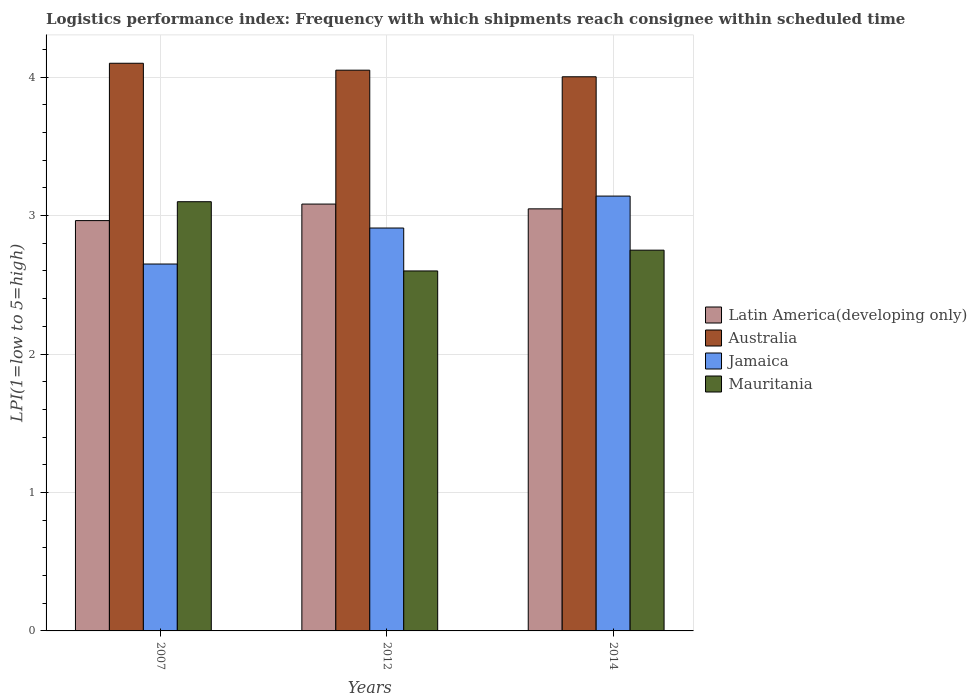How many different coloured bars are there?
Offer a very short reply. 4. Are the number of bars on each tick of the X-axis equal?
Your answer should be very brief. Yes. How many bars are there on the 3rd tick from the left?
Make the answer very short. 4. How many bars are there on the 1st tick from the right?
Give a very brief answer. 4. In how many cases, is the number of bars for a given year not equal to the number of legend labels?
Keep it short and to the point. 0. What is the logistics performance index in Jamaica in 2012?
Give a very brief answer. 2.91. Across all years, what is the maximum logistics performance index in Jamaica?
Keep it short and to the point. 3.14. Across all years, what is the minimum logistics performance index in Jamaica?
Offer a very short reply. 2.65. In which year was the logistics performance index in Mauritania maximum?
Your response must be concise. 2007. What is the total logistics performance index in Australia in the graph?
Make the answer very short. 12.15. What is the difference between the logistics performance index in Mauritania in 2007 and that in 2014?
Your response must be concise. 0.35. What is the difference between the logistics performance index in Mauritania in 2007 and the logistics performance index in Australia in 2012?
Ensure brevity in your answer.  -0.95. What is the average logistics performance index in Latin America(developing only) per year?
Ensure brevity in your answer.  3.03. In the year 2012, what is the difference between the logistics performance index in Jamaica and logistics performance index in Australia?
Give a very brief answer. -1.14. In how many years, is the logistics performance index in Latin America(developing only) greater than 0.8?
Offer a terse response. 3. What is the ratio of the logistics performance index in Australia in 2012 to that in 2014?
Offer a terse response. 1.01. Is the logistics performance index in Latin America(developing only) in 2012 less than that in 2014?
Provide a short and direct response. No. What is the difference between the highest and the second highest logistics performance index in Australia?
Ensure brevity in your answer.  0.05. What is the difference between the highest and the lowest logistics performance index in Australia?
Give a very brief answer. 0.1. In how many years, is the logistics performance index in Latin America(developing only) greater than the average logistics performance index in Latin America(developing only) taken over all years?
Your answer should be very brief. 2. Is the sum of the logistics performance index in Australia in 2007 and 2014 greater than the maximum logistics performance index in Jamaica across all years?
Provide a succinct answer. Yes. What does the 1st bar from the left in 2012 represents?
Give a very brief answer. Latin America(developing only). How many bars are there?
Offer a terse response. 12. How many years are there in the graph?
Give a very brief answer. 3. Are the values on the major ticks of Y-axis written in scientific E-notation?
Provide a succinct answer. No. Does the graph contain any zero values?
Ensure brevity in your answer.  No. Where does the legend appear in the graph?
Provide a short and direct response. Center right. What is the title of the graph?
Provide a succinct answer. Logistics performance index: Frequency with which shipments reach consignee within scheduled time. What is the label or title of the X-axis?
Make the answer very short. Years. What is the label or title of the Y-axis?
Offer a very short reply. LPI(1=low to 5=high). What is the LPI(1=low to 5=high) in Latin America(developing only) in 2007?
Ensure brevity in your answer.  2.96. What is the LPI(1=low to 5=high) of Jamaica in 2007?
Make the answer very short. 2.65. What is the LPI(1=low to 5=high) in Latin America(developing only) in 2012?
Make the answer very short. 3.08. What is the LPI(1=low to 5=high) in Australia in 2012?
Make the answer very short. 4.05. What is the LPI(1=low to 5=high) of Jamaica in 2012?
Offer a very short reply. 2.91. What is the LPI(1=low to 5=high) in Latin America(developing only) in 2014?
Keep it short and to the point. 3.05. What is the LPI(1=low to 5=high) in Australia in 2014?
Your answer should be very brief. 4. What is the LPI(1=low to 5=high) of Jamaica in 2014?
Provide a short and direct response. 3.14. What is the LPI(1=low to 5=high) of Mauritania in 2014?
Your answer should be compact. 2.75. Across all years, what is the maximum LPI(1=low to 5=high) of Latin America(developing only)?
Your response must be concise. 3.08. Across all years, what is the maximum LPI(1=low to 5=high) of Jamaica?
Offer a terse response. 3.14. Across all years, what is the minimum LPI(1=low to 5=high) of Latin America(developing only)?
Your response must be concise. 2.96. Across all years, what is the minimum LPI(1=low to 5=high) in Australia?
Your answer should be very brief. 4. Across all years, what is the minimum LPI(1=low to 5=high) of Jamaica?
Ensure brevity in your answer.  2.65. What is the total LPI(1=low to 5=high) in Latin America(developing only) in the graph?
Your answer should be compact. 9.09. What is the total LPI(1=low to 5=high) of Australia in the graph?
Your response must be concise. 12.15. What is the total LPI(1=low to 5=high) in Jamaica in the graph?
Make the answer very short. 8.7. What is the total LPI(1=low to 5=high) in Mauritania in the graph?
Offer a very short reply. 8.45. What is the difference between the LPI(1=low to 5=high) in Latin America(developing only) in 2007 and that in 2012?
Give a very brief answer. -0.12. What is the difference between the LPI(1=low to 5=high) of Australia in 2007 and that in 2012?
Make the answer very short. 0.05. What is the difference between the LPI(1=low to 5=high) in Jamaica in 2007 and that in 2012?
Provide a short and direct response. -0.26. What is the difference between the LPI(1=low to 5=high) of Latin America(developing only) in 2007 and that in 2014?
Provide a succinct answer. -0.08. What is the difference between the LPI(1=low to 5=high) in Australia in 2007 and that in 2014?
Your answer should be very brief. 0.1. What is the difference between the LPI(1=low to 5=high) in Jamaica in 2007 and that in 2014?
Keep it short and to the point. -0.49. What is the difference between the LPI(1=low to 5=high) in Latin America(developing only) in 2012 and that in 2014?
Offer a very short reply. 0.03. What is the difference between the LPI(1=low to 5=high) of Australia in 2012 and that in 2014?
Your response must be concise. 0.05. What is the difference between the LPI(1=low to 5=high) of Jamaica in 2012 and that in 2014?
Provide a succinct answer. -0.23. What is the difference between the LPI(1=low to 5=high) of Latin America(developing only) in 2007 and the LPI(1=low to 5=high) of Australia in 2012?
Keep it short and to the point. -1.09. What is the difference between the LPI(1=low to 5=high) in Latin America(developing only) in 2007 and the LPI(1=low to 5=high) in Jamaica in 2012?
Offer a very short reply. 0.05. What is the difference between the LPI(1=low to 5=high) of Latin America(developing only) in 2007 and the LPI(1=low to 5=high) of Mauritania in 2012?
Provide a succinct answer. 0.36. What is the difference between the LPI(1=low to 5=high) of Australia in 2007 and the LPI(1=low to 5=high) of Jamaica in 2012?
Your response must be concise. 1.19. What is the difference between the LPI(1=low to 5=high) in Australia in 2007 and the LPI(1=low to 5=high) in Mauritania in 2012?
Ensure brevity in your answer.  1.5. What is the difference between the LPI(1=low to 5=high) in Latin America(developing only) in 2007 and the LPI(1=low to 5=high) in Australia in 2014?
Provide a short and direct response. -1.04. What is the difference between the LPI(1=low to 5=high) in Latin America(developing only) in 2007 and the LPI(1=low to 5=high) in Jamaica in 2014?
Your answer should be very brief. -0.18. What is the difference between the LPI(1=low to 5=high) in Latin America(developing only) in 2007 and the LPI(1=low to 5=high) in Mauritania in 2014?
Provide a succinct answer. 0.21. What is the difference between the LPI(1=low to 5=high) of Australia in 2007 and the LPI(1=low to 5=high) of Jamaica in 2014?
Give a very brief answer. 0.96. What is the difference between the LPI(1=low to 5=high) of Australia in 2007 and the LPI(1=low to 5=high) of Mauritania in 2014?
Ensure brevity in your answer.  1.35. What is the difference between the LPI(1=low to 5=high) of Jamaica in 2007 and the LPI(1=low to 5=high) of Mauritania in 2014?
Keep it short and to the point. -0.1. What is the difference between the LPI(1=low to 5=high) in Latin America(developing only) in 2012 and the LPI(1=low to 5=high) in Australia in 2014?
Offer a terse response. -0.92. What is the difference between the LPI(1=low to 5=high) of Latin America(developing only) in 2012 and the LPI(1=low to 5=high) of Jamaica in 2014?
Offer a very short reply. -0.06. What is the difference between the LPI(1=low to 5=high) in Latin America(developing only) in 2012 and the LPI(1=low to 5=high) in Mauritania in 2014?
Offer a very short reply. 0.33. What is the difference between the LPI(1=low to 5=high) of Australia in 2012 and the LPI(1=low to 5=high) of Jamaica in 2014?
Make the answer very short. 0.91. What is the difference between the LPI(1=low to 5=high) of Jamaica in 2012 and the LPI(1=low to 5=high) of Mauritania in 2014?
Give a very brief answer. 0.16. What is the average LPI(1=low to 5=high) of Latin America(developing only) per year?
Your answer should be compact. 3.03. What is the average LPI(1=low to 5=high) in Australia per year?
Your response must be concise. 4.05. What is the average LPI(1=low to 5=high) in Jamaica per year?
Provide a short and direct response. 2.9. What is the average LPI(1=low to 5=high) of Mauritania per year?
Give a very brief answer. 2.82. In the year 2007, what is the difference between the LPI(1=low to 5=high) in Latin America(developing only) and LPI(1=low to 5=high) in Australia?
Provide a succinct answer. -1.14. In the year 2007, what is the difference between the LPI(1=low to 5=high) in Latin America(developing only) and LPI(1=low to 5=high) in Jamaica?
Make the answer very short. 0.31. In the year 2007, what is the difference between the LPI(1=low to 5=high) in Latin America(developing only) and LPI(1=low to 5=high) in Mauritania?
Offer a terse response. -0.14. In the year 2007, what is the difference between the LPI(1=low to 5=high) in Australia and LPI(1=low to 5=high) in Jamaica?
Your answer should be compact. 1.45. In the year 2007, what is the difference between the LPI(1=low to 5=high) of Australia and LPI(1=low to 5=high) of Mauritania?
Keep it short and to the point. 1. In the year 2007, what is the difference between the LPI(1=low to 5=high) in Jamaica and LPI(1=low to 5=high) in Mauritania?
Make the answer very short. -0.45. In the year 2012, what is the difference between the LPI(1=low to 5=high) in Latin America(developing only) and LPI(1=low to 5=high) in Australia?
Your response must be concise. -0.97. In the year 2012, what is the difference between the LPI(1=low to 5=high) in Latin America(developing only) and LPI(1=low to 5=high) in Jamaica?
Ensure brevity in your answer.  0.17. In the year 2012, what is the difference between the LPI(1=low to 5=high) in Latin America(developing only) and LPI(1=low to 5=high) in Mauritania?
Offer a terse response. 0.48. In the year 2012, what is the difference between the LPI(1=low to 5=high) in Australia and LPI(1=low to 5=high) in Jamaica?
Your answer should be very brief. 1.14. In the year 2012, what is the difference between the LPI(1=low to 5=high) in Australia and LPI(1=low to 5=high) in Mauritania?
Offer a terse response. 1.45. In the year 2012, what is the difference between the LPI(1=low to 5=high) in Jamaica and LPI(1=low to 5=high) in Mauritania?
Give a very brief answer. 0.31. In the year 2014, what is the difference between the LPI(1=low to 5=high) in Latin America(developing only) and LPI(1=low to 5=high) in Australia?
Offer a terse response. -0.95. In the year 2014, what is the difference between the LPI(1=low to 5=high) in Latin America(developing only) and LPI(1=low to 5=high) in Jamaica?
Your answer should be very brief. -0.09. In the year 2014, what is the difference between the LPI(1=low to 5=high) in Latin America(developing only) and LPI(1=low to 5=high) in Mauritania?
Offer a very short reply. 0.3. In the year 2014, what is the difference between the LPI(1=low to 5=high) of Australia and LPI(1=low to 5=high) of Jamaica?
Ensure brevity in your answer.  0.86. In the year 2014, what is the difference between the LPI(1=low to 5=high) in Australia and LPI(1=low to 5=high) in Mauritania?
Your response must be concise. 1.25. In the year 2014, what is the difference between the LPI(1=low to 5=high) in Jamaica and LPI(1=low to 5=high) in Mauritania?
Offer a terse response. 0.39. What is the ratio of the LPI(1=low to 5=high) in Latin America(developing only) in 2007 to that in 2012?
Provide a short and direct response. 0.96. What is the ratio of the LPI(1=low to 5=high) of Australia in 2007 to that in 2012?
Your answer should be compact. 1.01. What is the ratio of the LPI(1=low to 5=high) of Jamaica in 2007 to that in 2012?
Provide a short and direct response. 0.91. What is the ratio of the LPI(1=low to 5=high) of Mauritania in 2007 to that in 2012?
Your answer should be very brief. 1.19. What is the ratio of the LPI(1=low to 5=high) in Latin America(developing only) in 2007 to that in 2014?
Offer a very short reply. 0.97. What is the ratio of the LPI(1=low to 5=high) in Australia in 2007 to that in 2014?
Make the answer very short. 1.02. What is the ratio of the LPI(1=low to 5=high) of Jamaica in 2007 to that in 2014?
Make the answer very short. 0.84. What is the ratio of the LPI(1=low to 5=high) in Mauritania in 2007 to that in 2014?
Give a very brief answer. 1.13. What is the ratio of the LPI(1=low to 5=high) in Latin America(developing only) in 2012 to that in 2014?
Your answer should be very brief. 1.01. What is the ratio of the LPI(1=low to 5=high) of Australia in 2012 to that in 2014?
Give a very brief answer. 1.01. What is the ratio of the LPI(1=low to 5=high) in Jamaica in 2012 to that in 2014?
Give a very brief answer. 0.93. What is the ratio of the LPI(1=low to 5=high) in Mauritania in 2012 to that in 2014?
Give a very brief answer. 0.95. What is the difference between the highest and the second highest LPI(1=low to 5=high) of Latin America(developing only)?
Ensure brevity in your answer.  0.03. What is the difference between the highest and the second highest LPI(1=low to 5=high) of Jamaica?
Offer a very short reply. 0.23. What is the difference between the highest and the lowest LPI(1=low to 5=high) in Latin America(developing only)?
Ensure brevity in your answer.  0.12. What is the difference between the highest and the lowest LPI(1=low to 5=high) in Australia?
Make the answer very short. 0.1. What is the difference between the highest and the lowest LPI(1=low to 5=high) of Jamaica?
Keep it short and to the point. 0.49. 